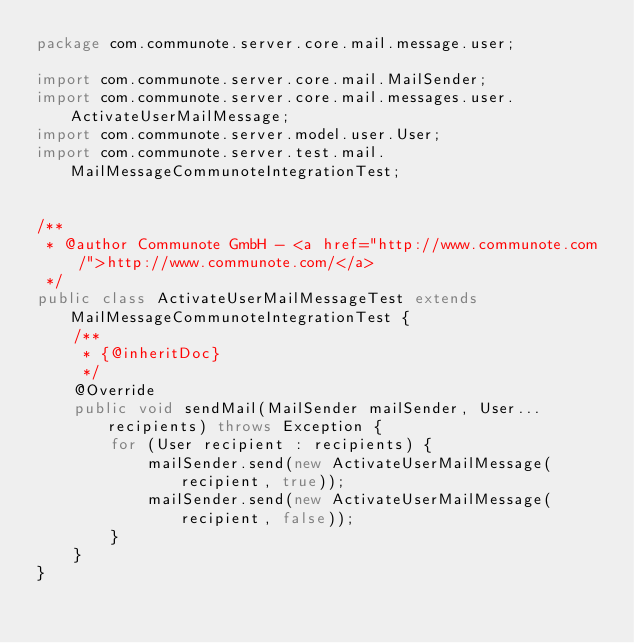Convert code to text. <code><loc_0><loc_0><loc_500><loc_500><_Java_>package com.communote.server.core.mail.message.user;

import com.communote.server.core.mail.MailSender;
import com.communote.server.core.mail.messages.user.ActivateUserMailMessage;
import com.communote.server.model.user.User;
import com.communote.server.test.mail.MailMessageCommunoteIntegrationTest;


/**
 * @author Communote GmbH - <a href="http://www.communote.com/">http://www.communote.com/</a>
 */
public class ActivateUserMailMessageTest extends MailMessageCommunoteIntegrationTest {
    /**
     * {@inheritDoc}
     */
    @Override
    public void sendMail(MailSender mailSender, User... recipients) throws Exception {
        for (User recipient : recipients) {
            mailSender.send(new ActivateUserMailMessage(recipient, true));
            mailSender.send(new ActivateUserMailMessage(recipient, false));
        }
    }
}
</code> 